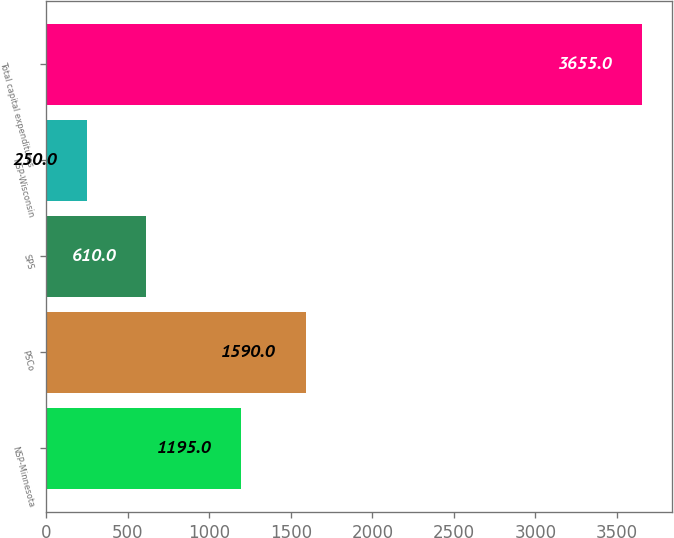<chart> <loc_0><loc_0><loc_500><loc_500><bar_chart><fcel>NSP-Minnesota<fcel>PSCo<fcel>SPS<fcel>NSP-Wisconsin<fcel>Total capital expenditures<nl><fcel>1195<fcel>1590<fcel>610<fcel>250<fcel>3655<nl></chart> 